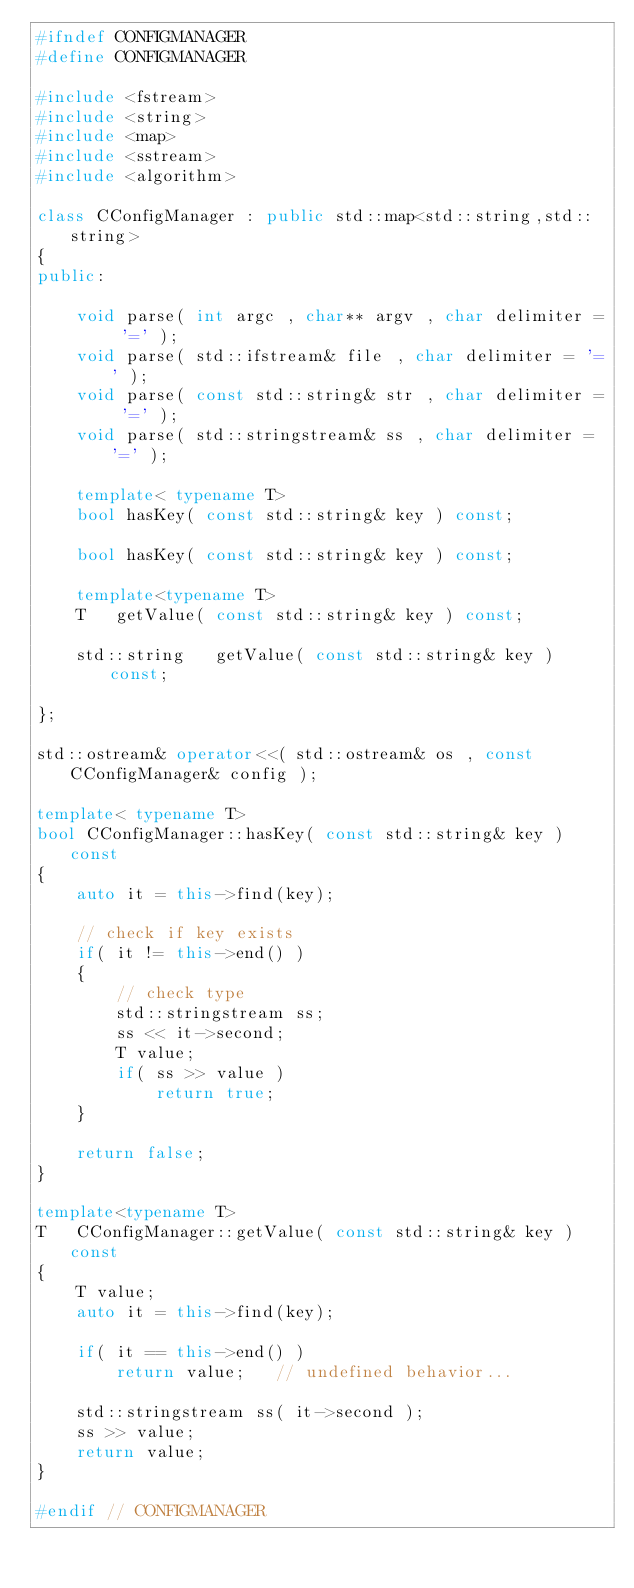Convert code to text. <code><loc_0><loc_0><loc_500><loc_500><_C++_>#ifndef CONFIGMANAGER
#define CONFIGMANAGER

#include <fstream>
#include <string>
#include <map>
#include <sstream>
#include <algorithm>

class CConfigManager : public std::map<std::string,std::string>
{
public:

    void parse( int argc , char** argv , char delimiter = '=' );
    void parse( std::ifstream& file , char delimiter = '=' );
    void parse( const std::string& str , char delimiter = '=' );
    void parse( std::stringstream& ss , char delimiter = '=' );

    template< typename T>
    bool hasKey( const std::string& key ) const;

    bool hasKey( const std::string& key ) const;

    template<typename T>
    T   getValue( const std::string& key ) const;

    std::string   getValue( const std::string& key ) const;

};

std::ostream& operator<<( std::ostream& os , const CConfigManager& config );

template< typename T>
bool CConfigManager::hasKey( const std::string& key ) const
{
    auto it = this->find(key);

    // check if key exists
    if( it != this->end() )
    {
        // check type
        std::stringstream ss;
        ss << it->second;
        T value;
        if( ss >> value )
            return true;
    }

    return false;
}

template<typename T>
T   CConfigManager::getValue( const std::string& key ) const
{
    T value;
    auto it = this->find(key);

    if( it == this->end() )
        return value;   // undefined behavior...

    std::stringstream ss( it->second );
    ss >> value;
    return value;
}

#endif // CONFIGMANAGER

</code> 